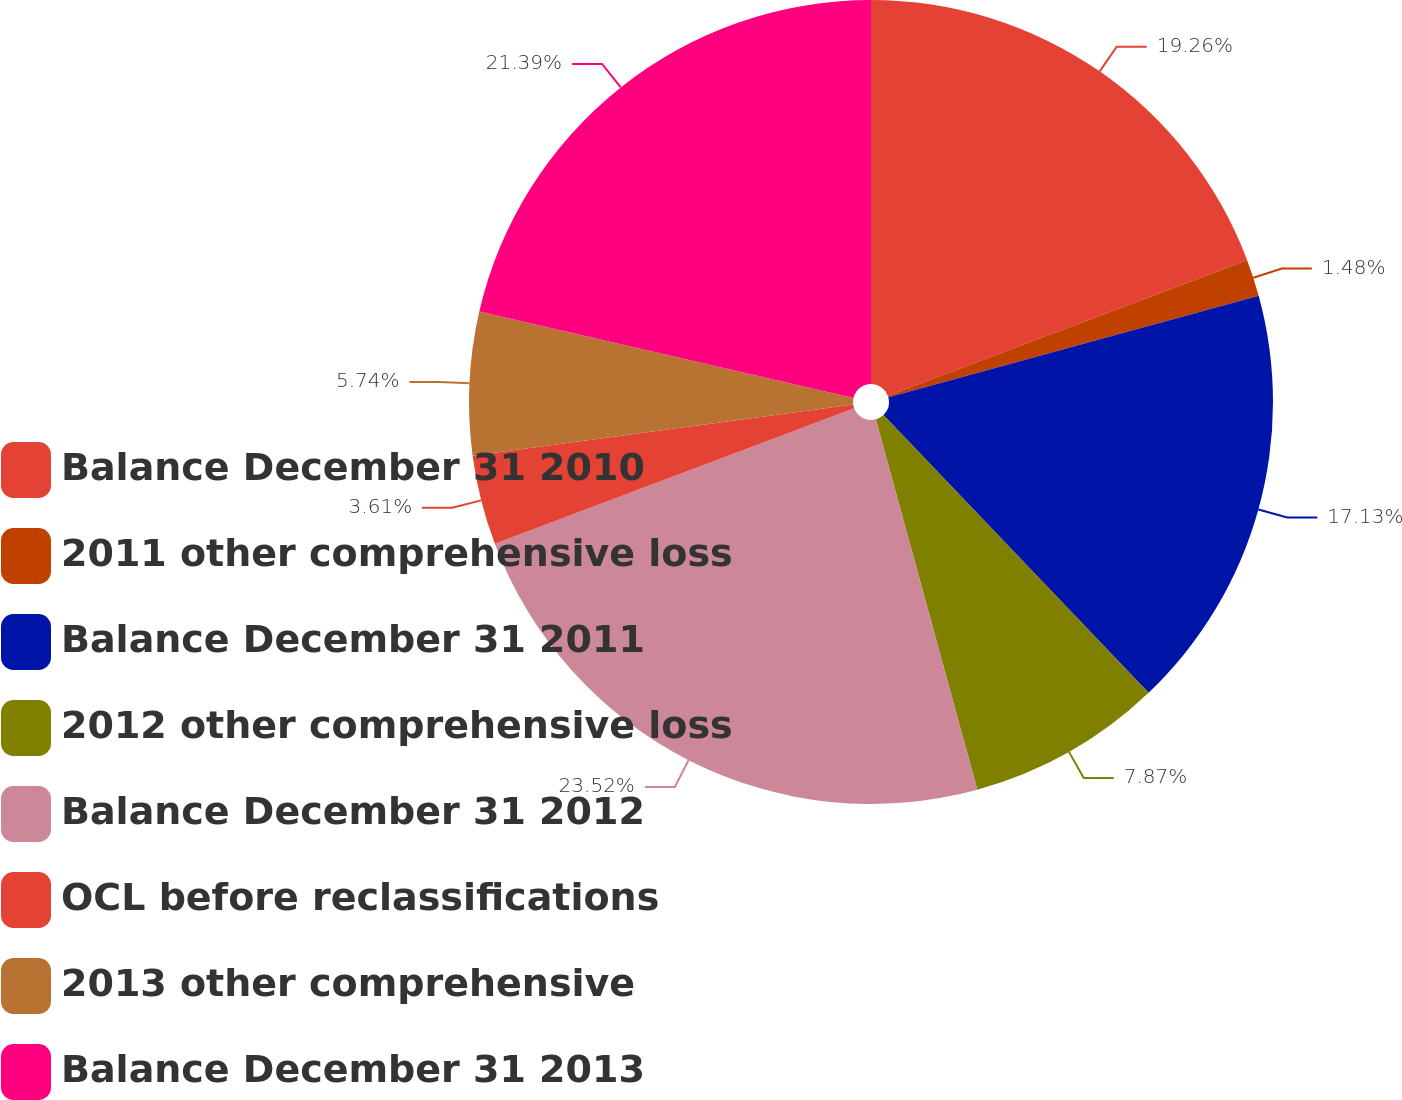<chart> <loc_0><loc_0><loc_500><loc_500><pie_chart><fcel>Balance December 31 2010<fcel>2011 other comprehensive loss<fcel>Balance December 31 2011<fcel>2012 other comprehensive loss<fcel>Balance December 31 2012<fcel>OCL before reclassifications<fcel>2013 other comprehensive<fcel>Balance December 31 2013<nl><fcel>19.26%<fcel>1.48%<fcel>17.13%<fcel>7.87%<fcel>23.52%<fcel>3.61%<fcel>5.74%<fcel>21.39%<nl></chart> 